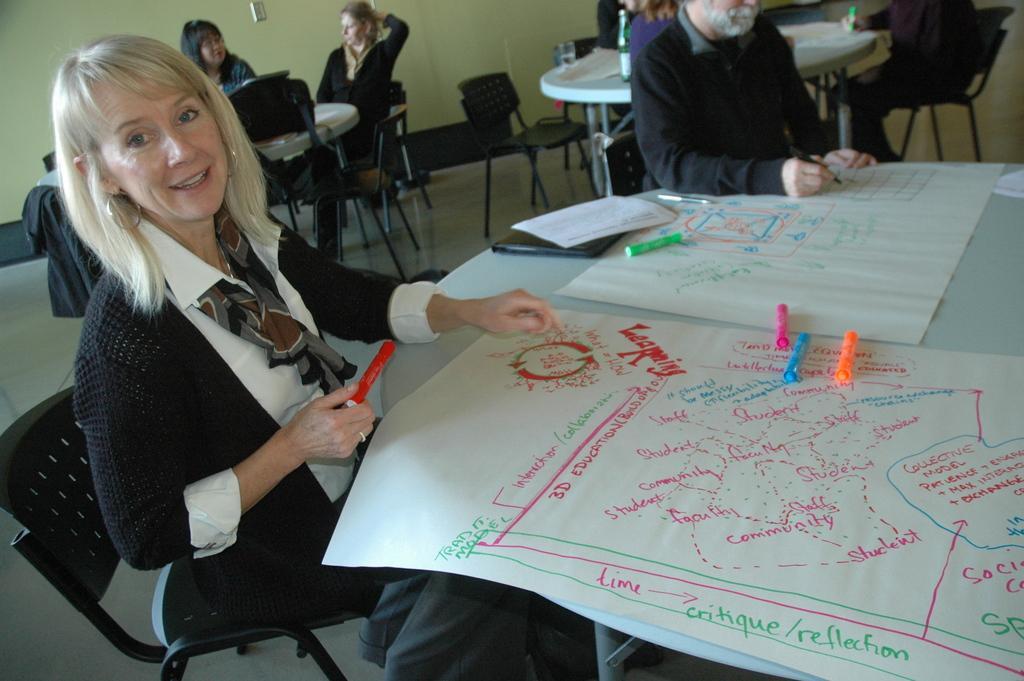Describe this image in one or two sentences. In this picture we can find a woman sitting on a chair near the table. On the table we can find pictures, charts, and sketches. In the background we can find some people are sitting on a chairs, and walls. 